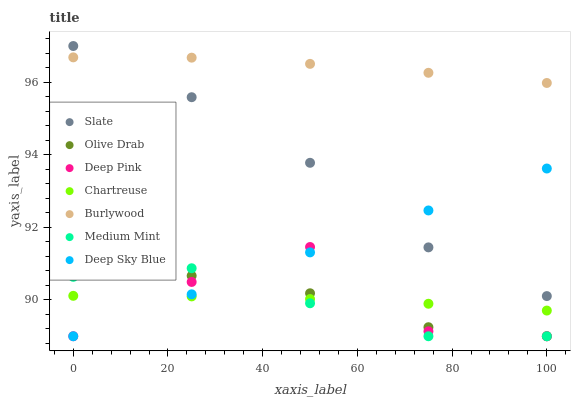Does Medium Mint have the minimum area under the curve?
Answer yes or no. Yes. Does Burlywood have the maximum area under the curve?
Answer yes or no. Yes. Does Deep Pink have the minimum area under the curve?
Answer yes or no. No. Does Deep Pink have the maximum area under the curve?
Answer yes or no. No. Is Deep Sky Blue the smoothest?
Answer yes or no. Yes. Is Deep Pink the roughest?
Answer yes or no. Yes. Is Burlywood the smoothest?
Answer yes or no. No. Is Burlywood the roughest?
Answer yes or no. No. Does Medium Mint have the lowest value?
Answer yes or no. Yes. Does Burlywood have the lowest value?
Answer yes or no. No. Does Slate have the highest value?
Answer yes or no. Yes. Does Deep Pink have the highest value?
Answer yes or no. No. Is Chartreuse less than Slate?
Answer yes or no. Yes. Is Slate greater than Olive Drab?
Answer yes or no. Yes. Does Slate intersect Deep Sky Blue?
Answer yes or no. Yes. Is Slate less than Deep Sky Blue?
Answer yes or no. No. Is Slate greater than Deep Sky Blue?
Answer yes or no. No. Does Chartreuse intersect Slate?
Answer yes or no. No. 